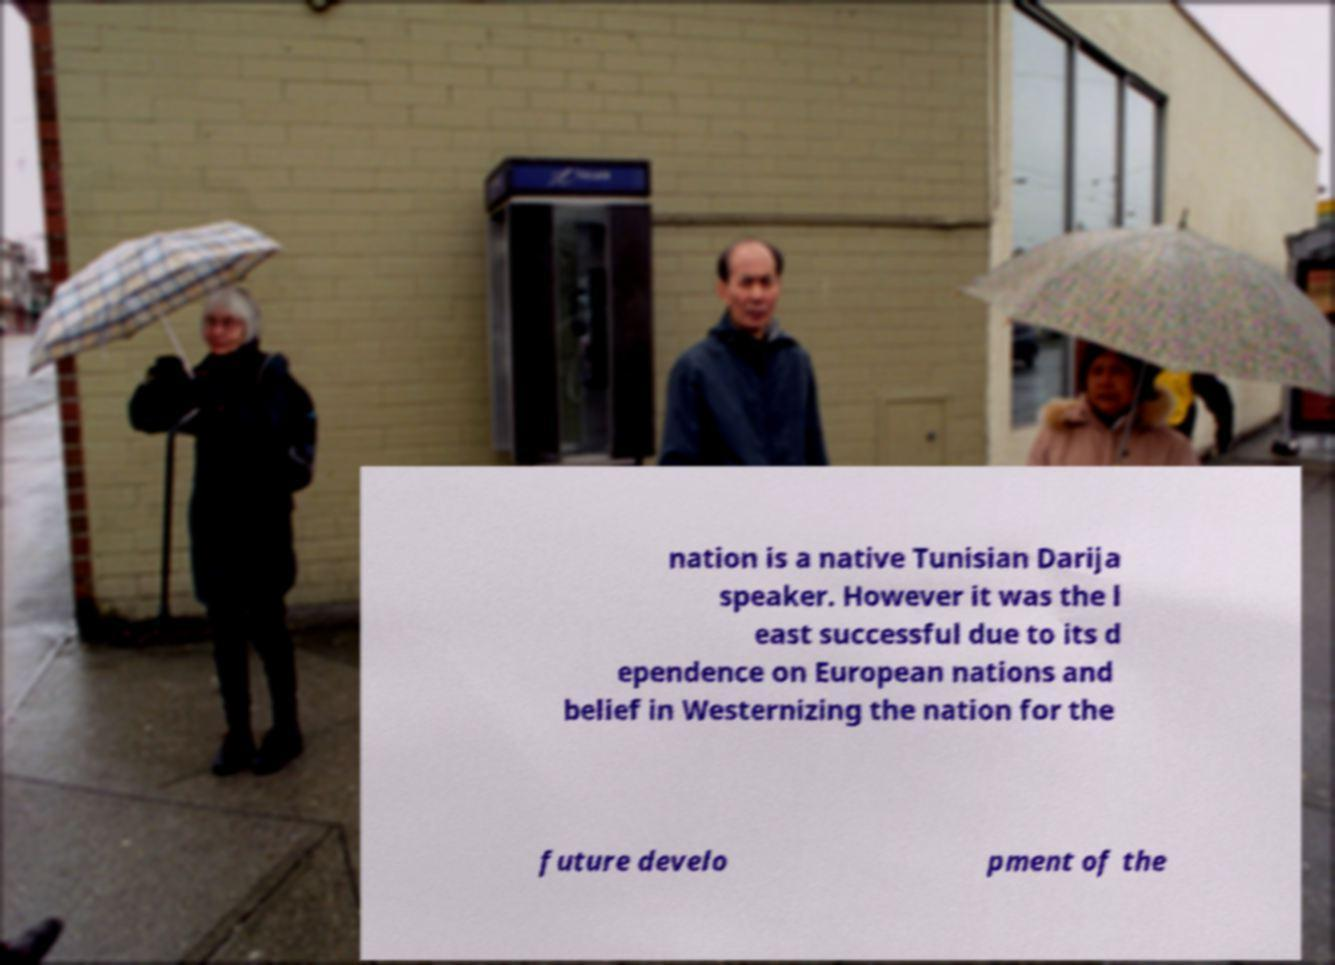Please read and relay the text visible in this image. What does it say? nation is a native Tunisian Darija speaker. However it was the l east successful due to its d ependence on European nations and belief in Westernizing the nation for the future develo pment of the 